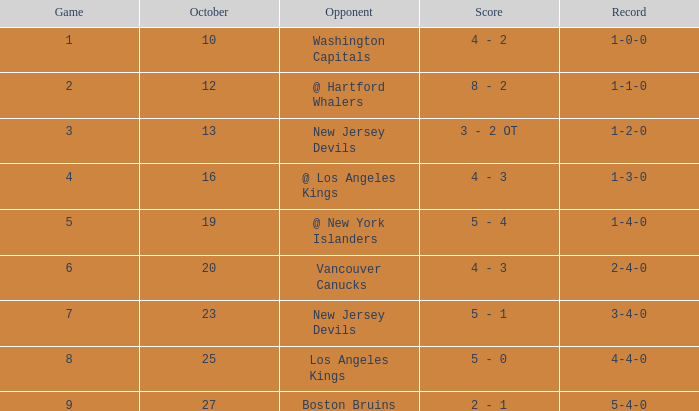What was the standard game with a record of 4-4-0? 8.0. 